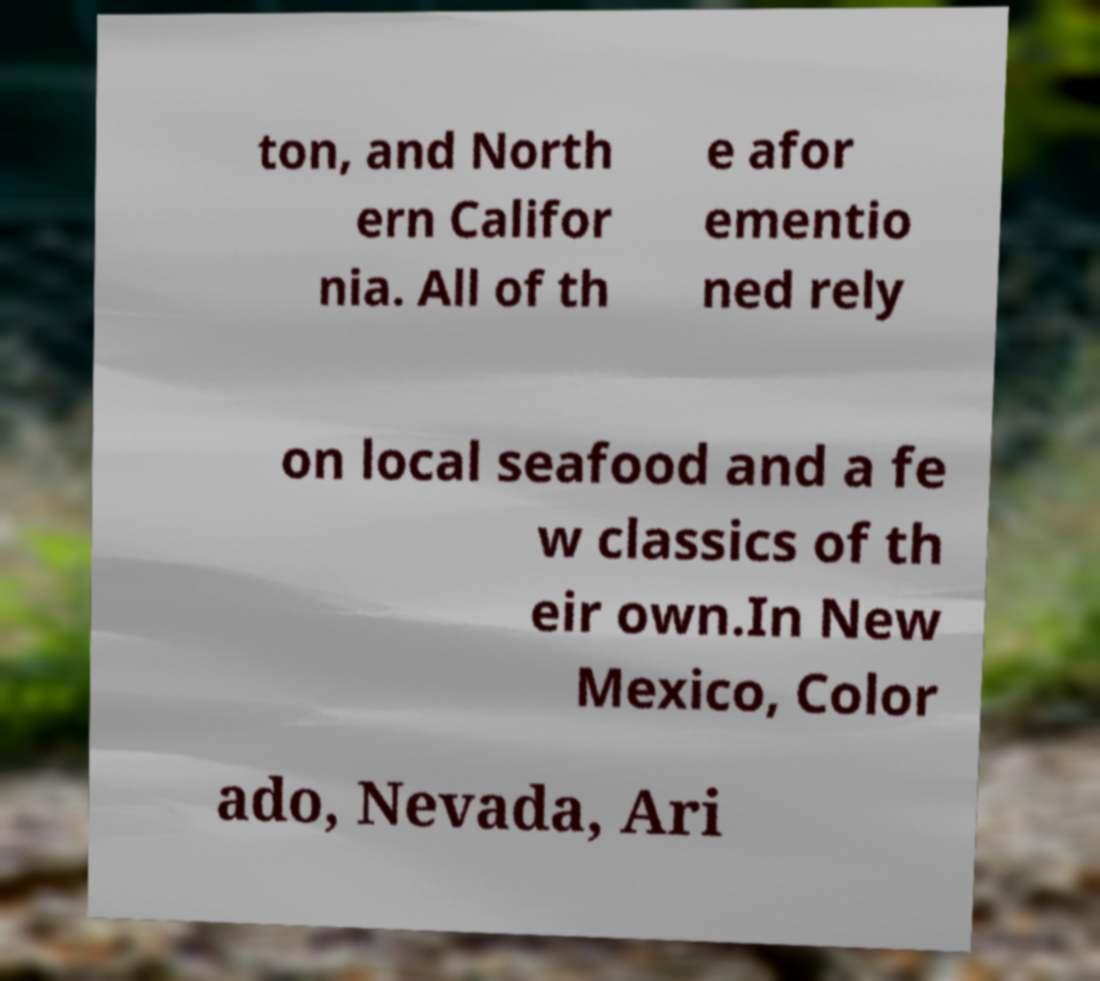There's text embedded in this image that I need extracted. Can you transcribe it verbatim? ton, and North ern Califor nia. All of th e afor ementio ned rely on local seafood and a fe w classics of th eir own.In New Mexico, Color ado, Nevada, Ari 